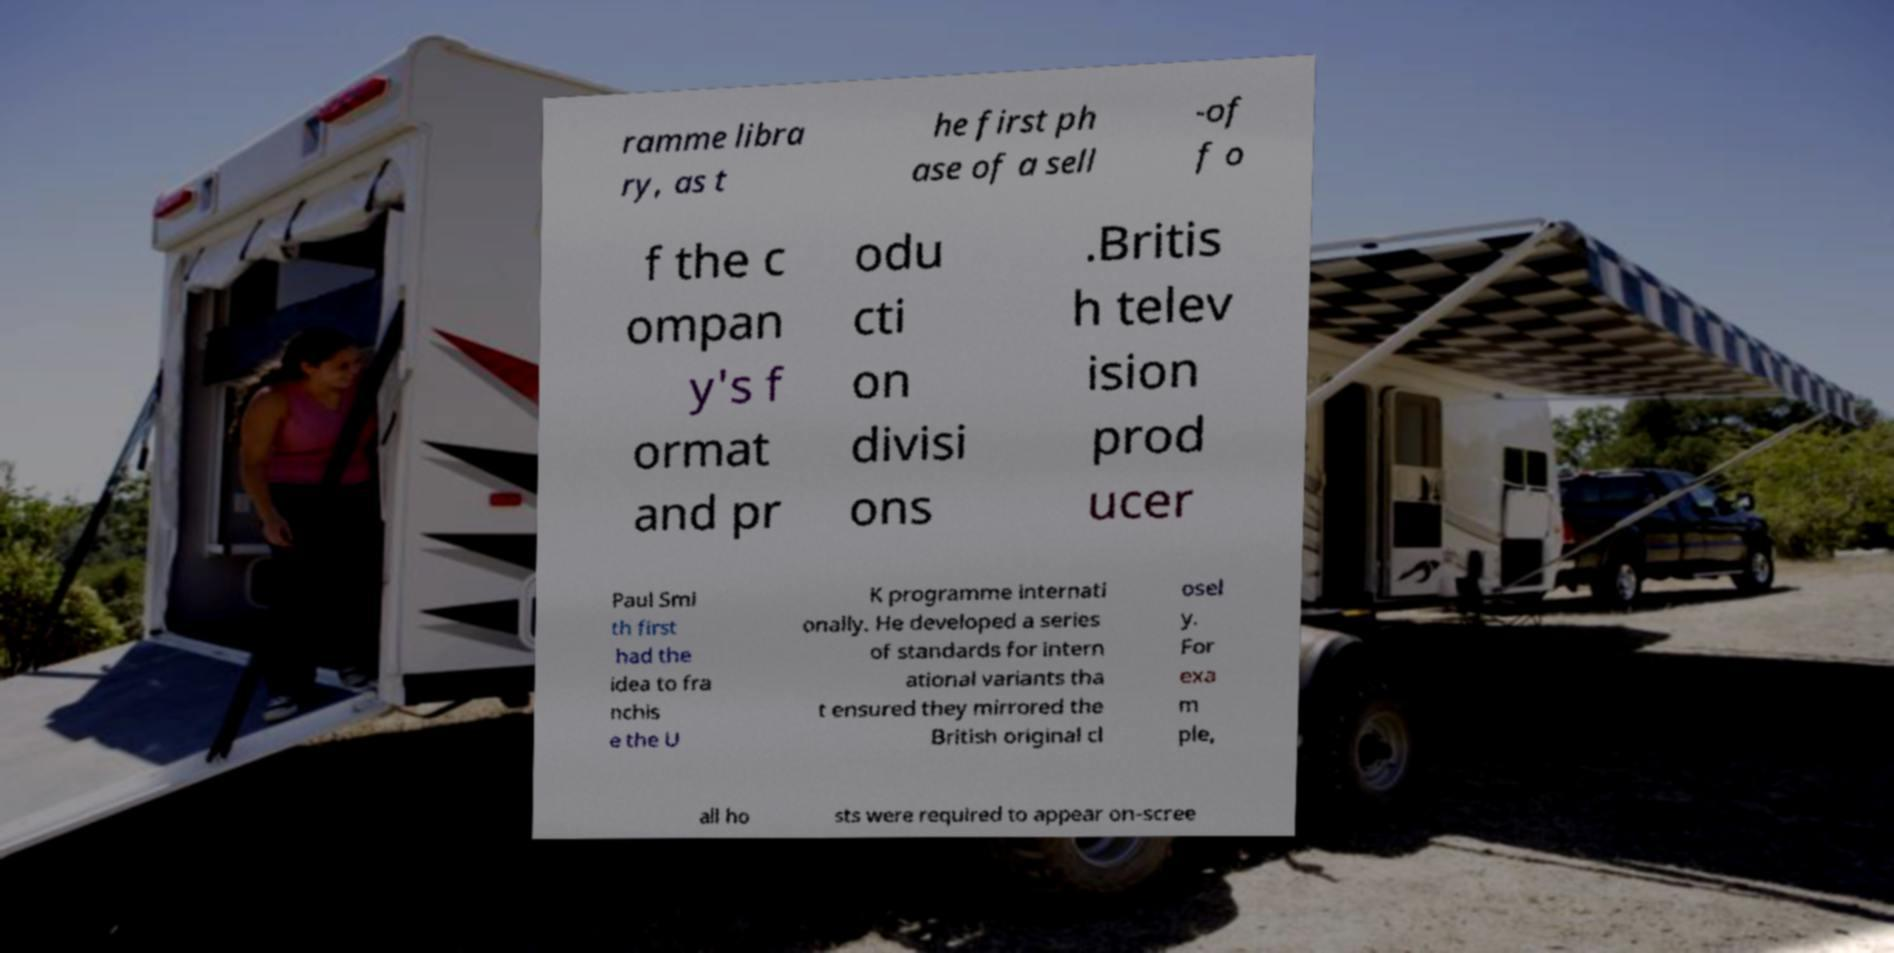Could you assist in decoding the text presented in this image and type it out clearly? ramme libra ry, as t he first ph ase of a sell -of f o f the c ompan y's f ormat and pr odu cti on divisi ons .Britis h telev ision prod ucer Paul Smi th first had the idea to fra nchis e the U K programme internati onally. He developed a series of standards for intern ational variants tha t ensured they mirrored the British original cl osel y. For exa m ple, all ho sts were required to appear on-scree 